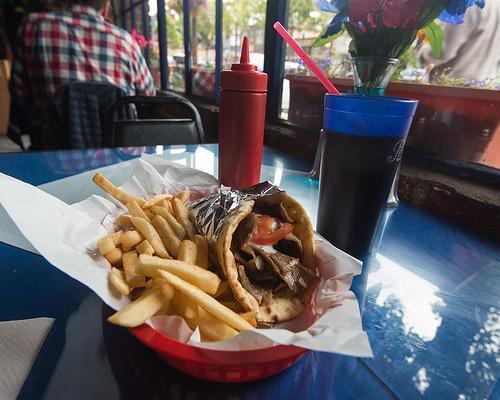How many dinosaurs are in the picture?
Give a very brief answer. 0. How many elephants are pictured?
Give a very brief answer. 0. 